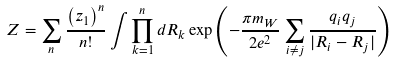<formula> <loc_0><loc_0><loc_500><loc_500>Z = \sum _ { n } { \frac { \left ( z _ { 1 } \right ) ^ { n } } { n ! } } \int \prod _ { k = 1 } ^ { n } d { R } _ { k } \exp \left ( - { \frac { \pi m _ { W } } { 2 e ^ { 2 } } } \sum _ { i \not = j } { \frac { q _ { i } q _ { j } } { | { R } _ { i } - { R } _ { j } | } } \right )</formula> 